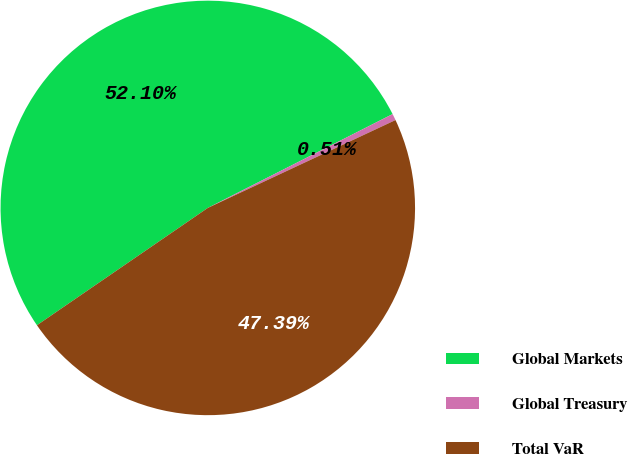<chart> <loc_0><loc_0><loc_500><loc_500><pie_chart><fcel>Global Markets<fcel>Global Treasury<fcel>Total VaR<nl><fcel>52.1%<fcel>0.51%<fcel>47.39%<nl></chart> 